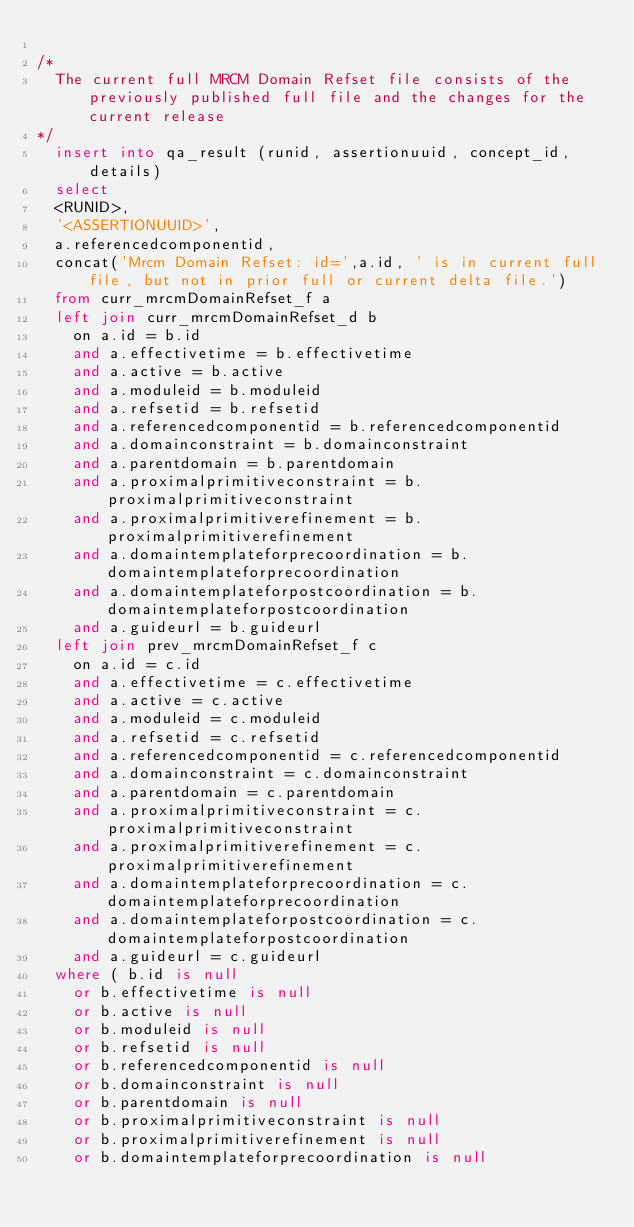Convert code to text. <code><loc_0><loc_0><loc_500><loc_500><_SQL_>
/*  
	The current full MRCM Domain Refset file consists of the previously published full file and the changes for the current release
*/
	insert into qa_result (runid, assertionuuid, concept_id, details)
	select 
	<RUNID>,
	'<ASSERTIONUUID>',
	a.referencedcomponentid,
	concat('Mrcm Domain Refset: id=',a.id, ' is in current full file, but not in prior full or current delta file.')
	from curr_mrcmDomainRefset_f a
	left join curr_mrcmDomainRefset_d b
		on a.id = b.id
		and a.effectivetime = b.effectivetime
		and a.active = b.active
		and a.moduleid = b.moduleid
		and a.refsetid = b.refsetid
		and a.referencedcomponentid = b.referencedcomponentid
		and a.domainconstraint = b.domainconstraint
		and a.parentdomain = b.parentdomain
		and a.proximalprimitiveconstraint = b.proximalprimitiveconstraint
		and a.proximalprimitiverefinement = b.proximalprimitiverefinement
		and a.domaintemplateforprecoordination = b.domaintemplateforprecoordination
		and a.domaintemplateforpostcoordination = b.domaintemplateforpostcoordination
		and a.guideurl = b.guideurl
	left join prev_mrcmDomainRefset_f c
		on a.id = c.id
		and a.effectivetime = c.effectivetime
		and a.active = c.active
		and a.moduleid = c.moduleid
		and a.refsetid = c.refsetid
		and a.referencedcomponentid = c.referencedcomponentid
		and a.domainconstraint = c.domainconstraint
		and a.parentdomain = c.parentdomain
		and a.proximalprimitiveconstraint = c.proximalprimitiveconstraint
		and a.proximalprimitiverefinement = c.proximalprimitiverefinement
		and a.domaintemplateforprecoordination = c.domaintemplateforprecoordination
		and a.domaintemplateforpostcoordination = c.domaintemplateforpostcoordination
		and a.guideurl = c.guideurl
	where ( b.id is null
		or b.effectivetime is null
		or b.active is null
		or b.moduleid is null
		or b.refsetid is null
		or b.referencedcomponentid is null
		or b.domainconstraint is null
		or b.parentdomain is null
		or b.proximalprimitiveconstraint is null
		or b.proximalprimitiverefinement is null
		or b.domaintemplateforprecoordination is null</code> 